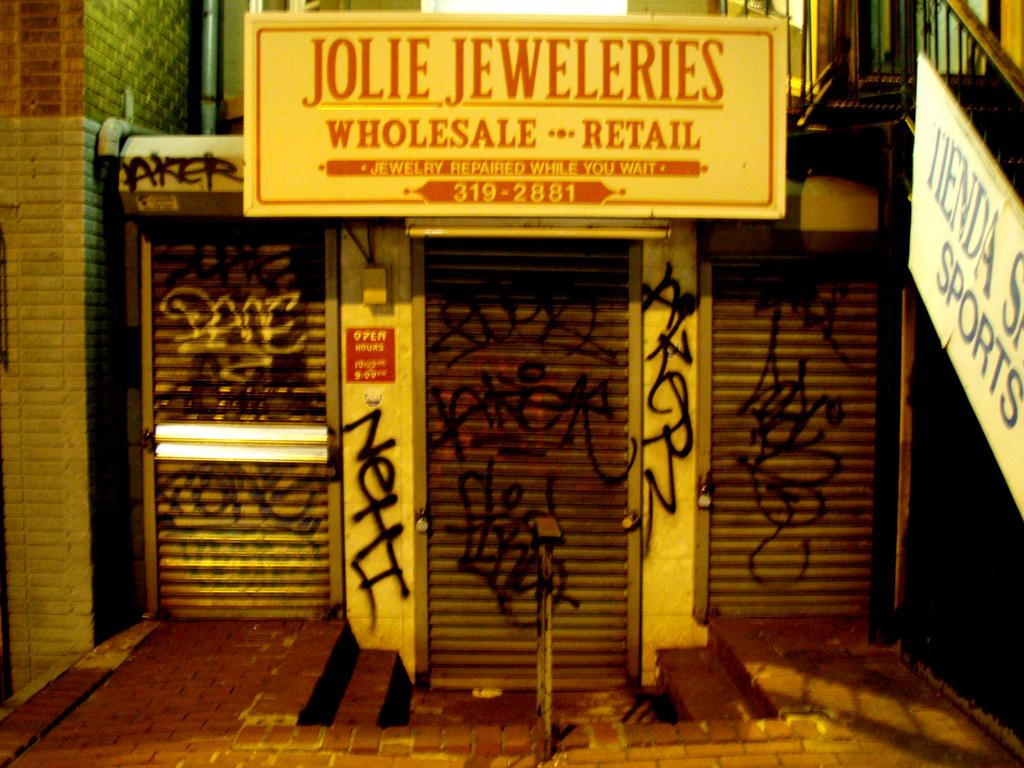<image>
Present a compact description of the photo's key features. Jolie Jeweleries, a wholesale retail shop that repairs while you wait, sits shuttered and covered in graffiti. 